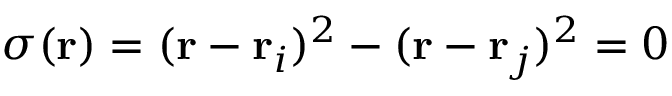<formula> <loc_0><loc_0><loc_500><loc_500>\sigma ( r ) = ( r - r _ { i } ) ^ { 2 } - ( r - r _ { j } ) ^ { 2 } = 0</formula> 